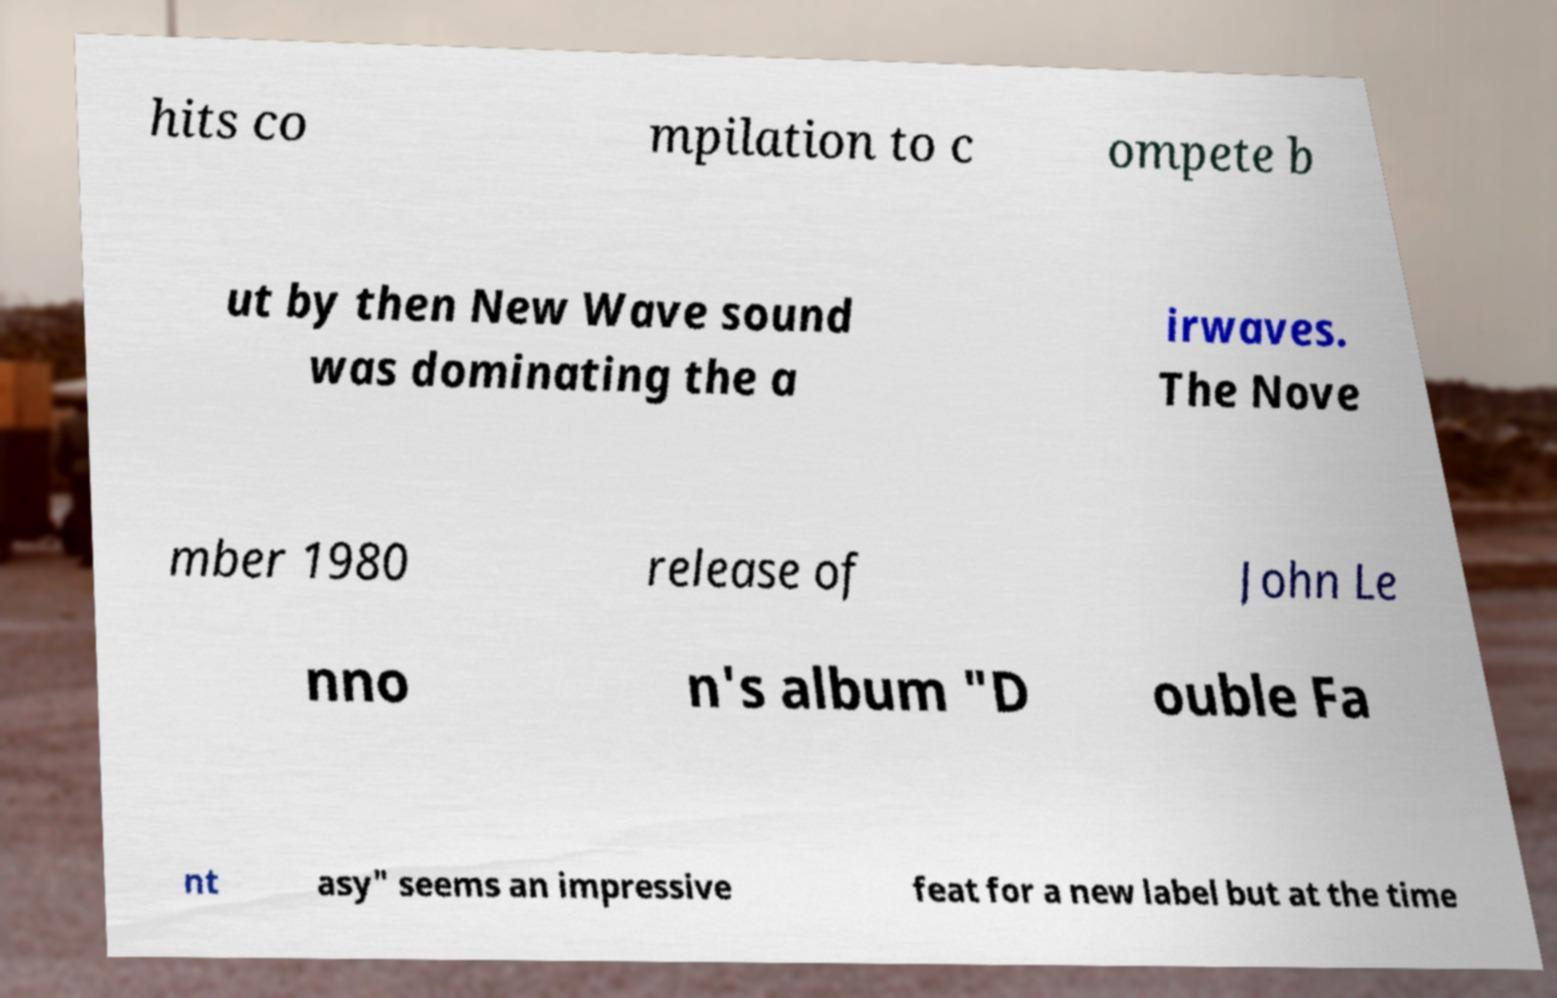Could you assist in decoding the text presented in this image and type it out clearly? hits co mpilation to c ompete b ut by then New Wave sound was dominating the a irwaves. The Nove mber 1980 release of John Le nno n's album "D ouble Fa nt asy" seems an impressive feat for a new label but at the time 